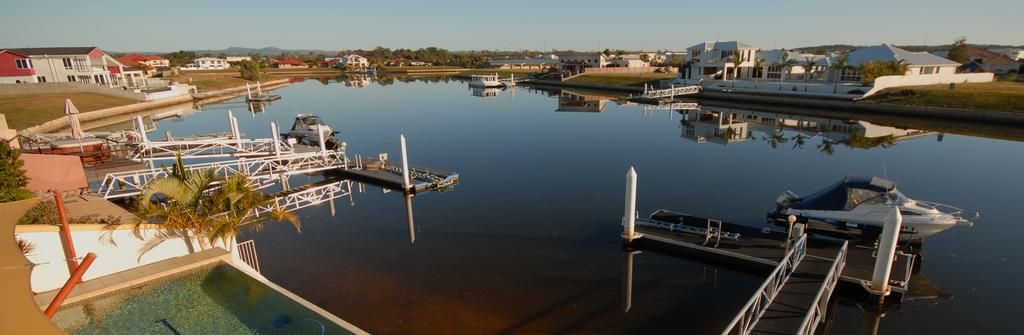What is the primary element in the image? The image consists of water, or is primarily made up of, water. What can be seen floating on the water? There are boats in the water. What structures are visible on the left side of the image? There are buildings on the left side of the image. What structures are visible on the right side of the image? There are buildings on the right side of the image. What type of vegetation is present along with the buildings? There are trees along with the buildings. What is visible at the top of the image? The sky is visible at the top of the image. What type of sock is being used to process the trousers in the image? There is no sock or trousers present in the image, and no process involving these items is depicted. 